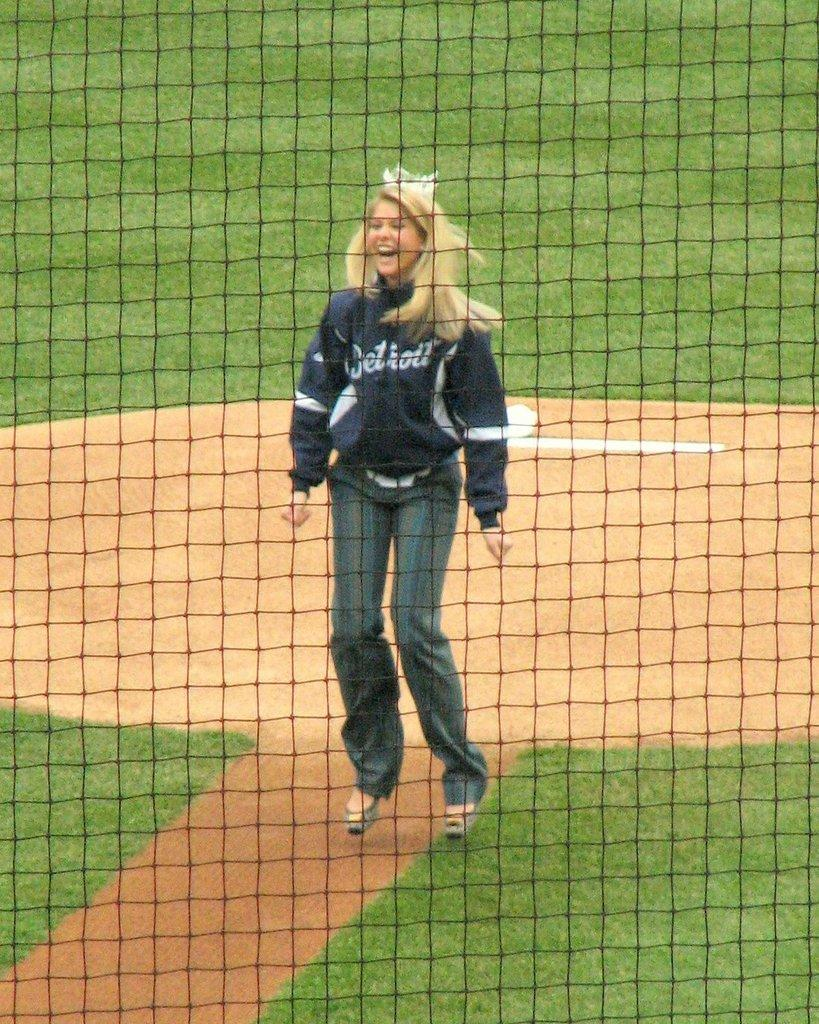What object is present in the image that is used for catching or holding? There is a net in the image. Who is present in the image besides the net? There is a woman standing in the image. How is the woman feeling or expressing herself in the image? The woman is laughing in the image. What type of surface is visible in the image? There is a grass surface in the image. What type of yak is present in the image? There is no yak present in the image. Who is the owner of the woman in the image? The concept of ownership does not apply to people in this context, and there is no indication of a family or owner in the image. 